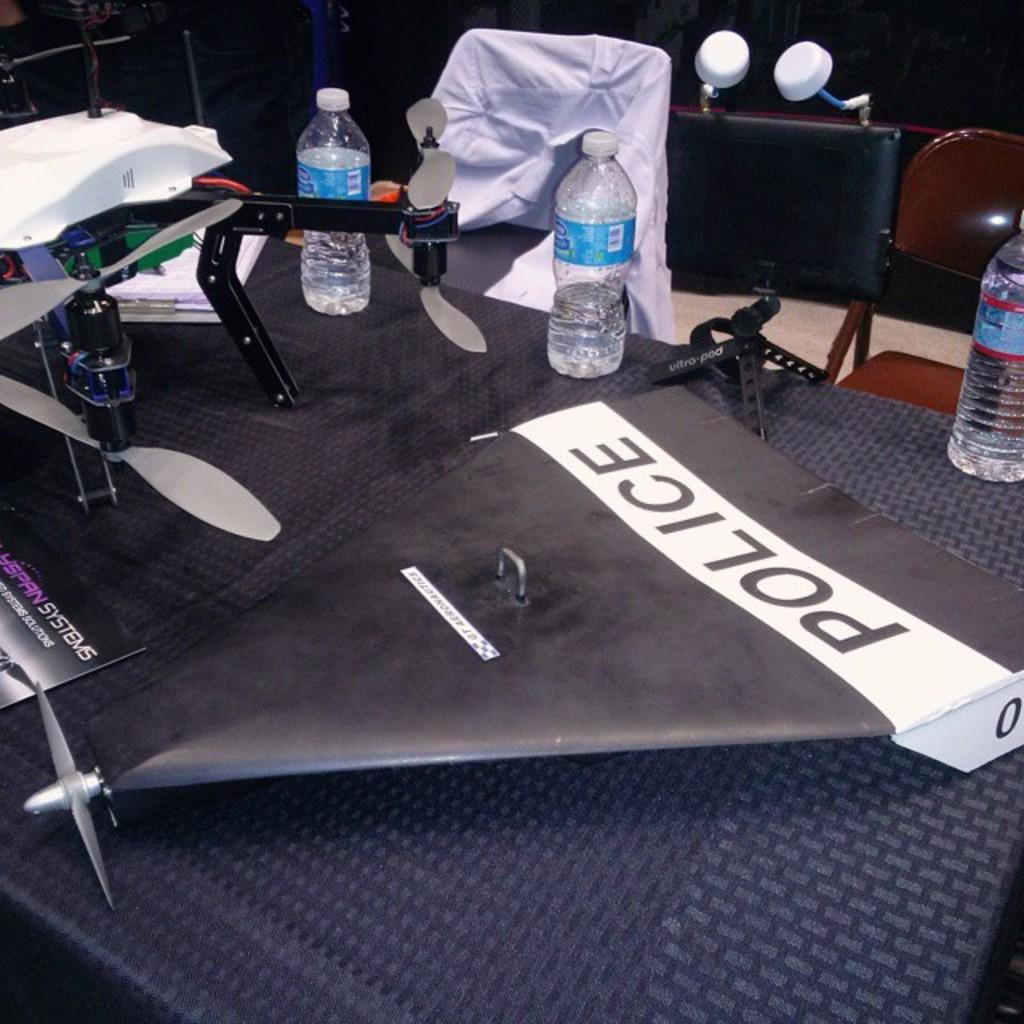What is the main object in the center of the image? There is a table in the center of the image. What items can be seen on the table? There are glasses, books, drones, and papers on the table. What is the purpose of the chairs in the background of the image? The chairs in the background of the image are likely for sitting. What type of soap is being used to clean the drones in the image? There is no soap present in the image, and the drones are not being cleaned. 